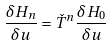<formula> <loc_0><loc_0><loc_500><loc_500>\frac { \delta H _ { n } } { \delta u } = \check { T } ^ { n } \frac { \delta H _ { 0 } } { \delta u }</formula> 